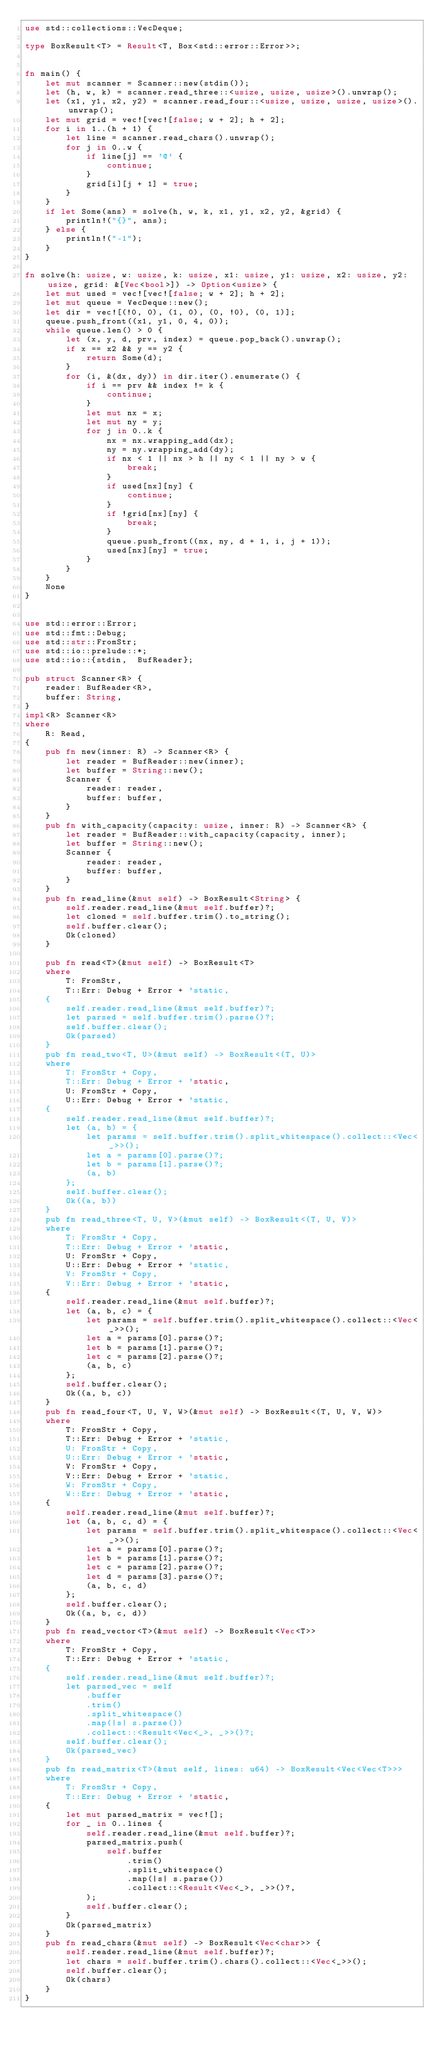Convert code to text. <code><loc_0><loc_0><loc_500><loc_500><_Rust_>use std::collections::VecDeque;

type BoxResult<T> = Result<T, Box<std::error::Error>>;


fn main() {
    let mut scanner = Scanner::new(stdin());
    let (h, w, k) = scanner.read_three::<usize, usize, usize>().unwrap();
    let (x1, y1, x2, y2) = scanner.read_four::<usize, usize, usize, usize>().unwrap();
    let mut grid = vec![vec![false; w + 2]; h + 2];
    for i in 1..(h + 1) {
        let line = scanner.read_chars().unwrap();
        for j in 0..w {
            if line[j] == '@' {
                continue;
            }
            grid[i][j + 1] = true;
        }
    }
    if let Some(ans) = solve(h, w, k, x1, y1, x2, y2, &grid) {
        println!("{}", ans);
    } else {
        println!("-1");
    }
}

fn solve(h: usize, w: usize, k: usize, x1: usize, y1: usize, x2: usize, y2: usize, grid: &[Vec<bool>]) -> Option<usize> {
    let mut used = vec![vec![false; w + 2]; h + 2];
    let mut queue = VecDeque::new();
    let dir = vec![(!0, 0), (1, 0), (0, !0), (0, 1)];
    queue.push_front((x1, y1, 0, 4, 0));
    while queue.len() > 0 {
        let (x, y, d, prv, index) = queue.pop_back().unwrap();
        if x == x2 && y == y2 {
            return Some(d);
        }
        for (i, &(dx, dy)) in dir.iter().enumerate() {
            if i == prv && index != k {
                continue;
            }
            let mut nx = x;
            let mut ny = y;
            for j in 0..k {
                nx = nx.wrapping_add(dx);
                ny = ny.wrapping_add(dy);
                if nx < 1 || nx > h || ny < 1 || ny > w {
                    break;
                }
                if used[nx][ny] {
                    continue;
                }
                if !grid[nx][ny] {
                    break;
                }
                queue.push_front((nx, ny, d + 1, i, j + 1));
                used[nx][ny] = true;
            }
        }
    }
    None
}


use std::error::Error;
use std::fmt::Debug;
use std::str::FromStr;
use std::io::prelude::*;
use std::io::{stdin,  BufReader};
 
pub struct Scanner<R> {
    reader: BufReader<R>,
    buffer: String,
}
impl<R> Scanner<R>
where
    R: Read,
{
    pub fn new(inner: R) -> Scanner<R> {
        let reader = BufReader::new(inner);
        let buffer = String::new();
        Scanner {
            reader: reader,
            buffer: buffer,
        }
    }
    pub fn with_capacity(capacity: usize, inner: R) -> Scanner<R> {
        let reader = BufReader::with_capacity(capacity, inner);
        let buffer = String::new();
        Scanner {
            reader: reader,
            buffer: buffer,
        }
    }
    pub fn read_line(&mut self) -> BoxResult<String> {
        self.reader.read_line(&mut self.buffer)?;
        let cloned = self.buffer.trim().to_string();
        self.buffer.clear();
        Ok(cloned)
    }
 
    pub fn read<T>(&mut self) -> BoxResult<T>
    where
        T: FromStr,
        T::Err: Debug + Error + 'static,
    {
        self.reader.read_line(&mut self.buffer)?;
        let parsed = self.buffer.trim().parse()?;
        self.buffer.clear();
        Ok(parsed)
    }
    pub fn read_two<T, U>(&mut self) -> BoxResult<(T, U)>
    where
        T: FromStr + Copy,
        T::Err: Debug + Error + 'static,
        U: FromStr + Copy,
        U::Err: Debug + Error + 'static,
    {
        self.reader.read_line(&mut self.buffer)?;
        let (a, b) = {
            let params = self.buffer.trim().split_whitespace().collect::<Vec<_>>();
            let a = params[0].parse()?;
            let b = params[1].parse()?;
            (a, b)
        };
        self.buffer.clear();
        Ok((a, b))
    }
    pub fn read_three<T, U, V>(&mut self) -> BoxResult<(T, U, V)>
    where
        T: FromStr + Copy,
        T::Err: Debug + Error + 'static,
        U: FromStr + Copy,
        U::Err: Debug + Error + 'static,
        V: FromStr + Copy,
        V::Err: Debug + Error + 'static,
    {
        self.reader.read_line(&mut self.buffer)?;
        let (a, b, c) = {
            let params = self.buffer.trim().split_whitespace().collect::<Vec<_>>();
            let a = params[0].parse()?;
            let b = params[1].parse()?;
            let c = params[2].parse()?;
            (a, b, c)
        };
        self.buffer.clear();
        Ok((a, b, c))
    }
    pub fn read_four<T, U, V, W>(&mut self) -> BoxResult<(T, U, V, W)>
    where
        T: FromStr + Copy,
        T::Err: Debug + Error + 'static,
        U: FromStr + Copy,
        U::Err: Debug + Error + 'static,
        V: FromStr + Copy,
        V::Err: Debug + Error + 'static,
        W: FromStr + Copy,
        W::Err: Debug + Error + 'static,
    {
        self.reader.read_line(&mut self.buffer)?;
        let (a, b, c, d) = {
            let params = self.buffer.trim().split_whitespace().collect::<Vec<_>>();
            let a = params[0].parse()?;
            let b = params[1].parse()?;
            let c = params[2].parse()?;
            let d = params[3].parse()?;
            (a, b, c, d)
        };
        self.buffer.clear();
        Ok((a, b, c, d))
    }
    pub fn read_vector<T>(&mut self) -> BoxResult<Vec<T>>
    where
        T: FromStr + Copy,
        T::Err: Debug + Error + 'static,
    {
        self.reader.read_line(&mut self.buffer)?;
        let parsed_vec = self
            .buffer
            .trim()
            .split_whitespace()
            .map(|s| s.parse())
            .collect::<Result<Vec<_>, _>>()?;
        self.buffer.clear();
        Ok(parsed_vec)
    }
    pub fn read_matrix<T>(&mut self, lines: u64) -> BoxResult<Vec<Vec<T>>>
    where
        T: FromStr + Copy,
        T::Err: Debug + Error + 'static,
    {
        let mut parsed_matrix = vec![];
        for _ in 0..lines {
            self.reader.read_line(&mut self.buffer)?;
            parsed_matrix.push(
                self.buffer
                    .trim()
                    .split_whitespace()
                    .map(|s| s.parse())
                    .collect::<Result<Vec<_>, _>>()?,
            );
            self.buffer.clear();
        }
        Ok(parsed_matrix)
    }
    pub fn read_chars(&mut self) -> BoxResult<Vec<char>> {
        self.reader.read_line(&mut self.buffer)?;
        let chars = self.buffer.trim().chars().collect::<Vec<_>>();
        self.buffer.clear();
        Ok(chars)
    }
}</code> 